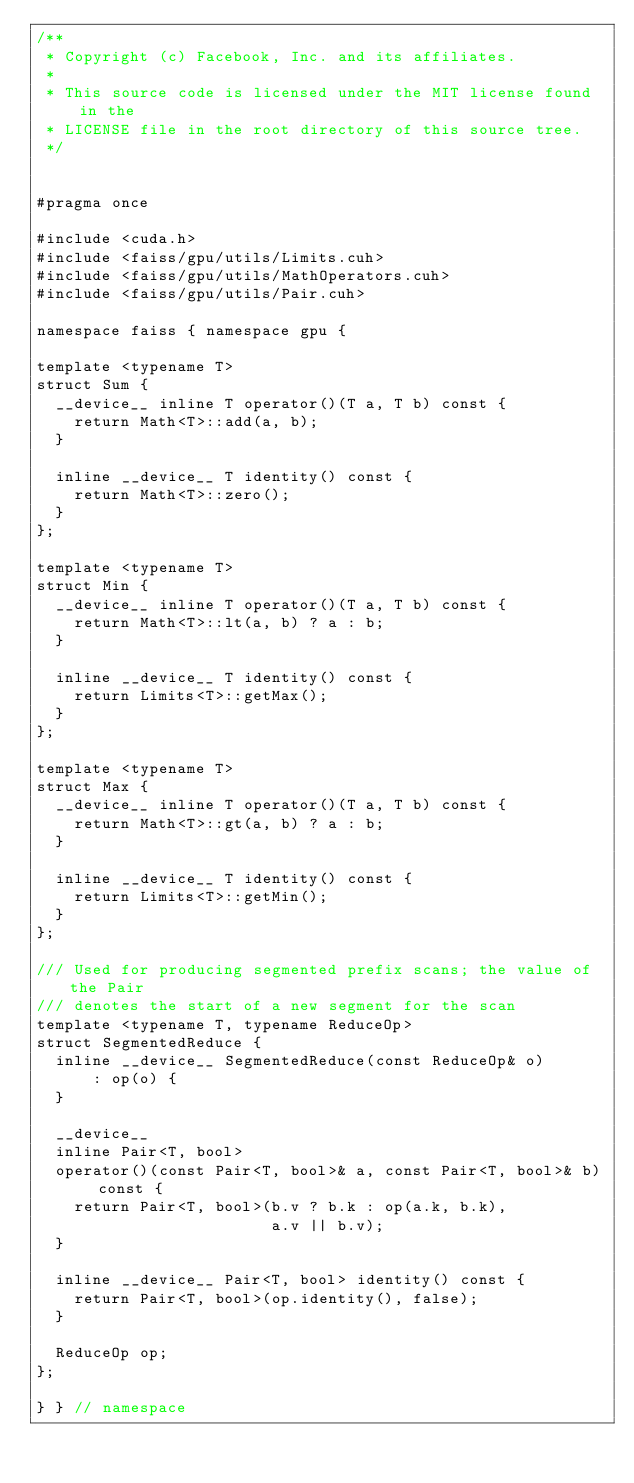Convert code to text. <code><loc_0><loc_0><loc_500><loc_500><_Cuda_>/**
 * Copyright (c) Facebook, Inc. and its affiliates.
 *
 * This source code is licensed under the MIT license found in the
 * LICENSE file in the root directory of this source tree.
 */


#pragma once

#include <cuda.h>
#include <faiss/gpu/utils/Limits.cuh>
#include <faiss/gpu/utils/MathOperators.cuh>
#include <faiss/gpu/utils/Pair.cuh>

namespace faiss { namespace gpu {

template <typename T>
struct Sum {
  __device__ inline T operator()(T a, T b) const {
    return Math<T>::add(a, b);
  }

  inline __device__ T identity() const {
    return Math<T>::zero();
  }
};

template <typename T>
struct Min {
  __device__ inline T operator()(T a, T b) const {
    return Math<T>::lt(a, b) ? a : b;
  }

  inline __device__ T identity() const {
    return Limits<T>::getMax();
  }
};

template <typename T>
struct Max {
  __device__ inline T operator()(T a, T b) const {
    return Math<T>::gt(a, b) ? a : b;
  }

  inline __device__ T identity() const {
    return Limits<T>::getMin();
  }
};

/// Used for producing segmented prefix scans; the value of the Pair
/// denotes the start of a new segment for the scan
template <typename T, typename ReduceOp>
struct SegmentedReduce {
  inline __device__ SegmentedReduce(const ReduceOp& o)
      : op(o) {
  }

  __device__
  inline Pair<T, bool>
  operator()(const Pair<T, bool>& a, const Pair<T, bool>& b) const {
    return Pair<T, bool>(b.v ? b.k : op(a.k, b.k),
                         a.v || b.v);
  }

  inline __device__ Pair<T, bool> identity() const {
    return Pair<T, bool>(op.identity(), false);
  }

  ReduceOp op;
};

} } // namespace
</code> 